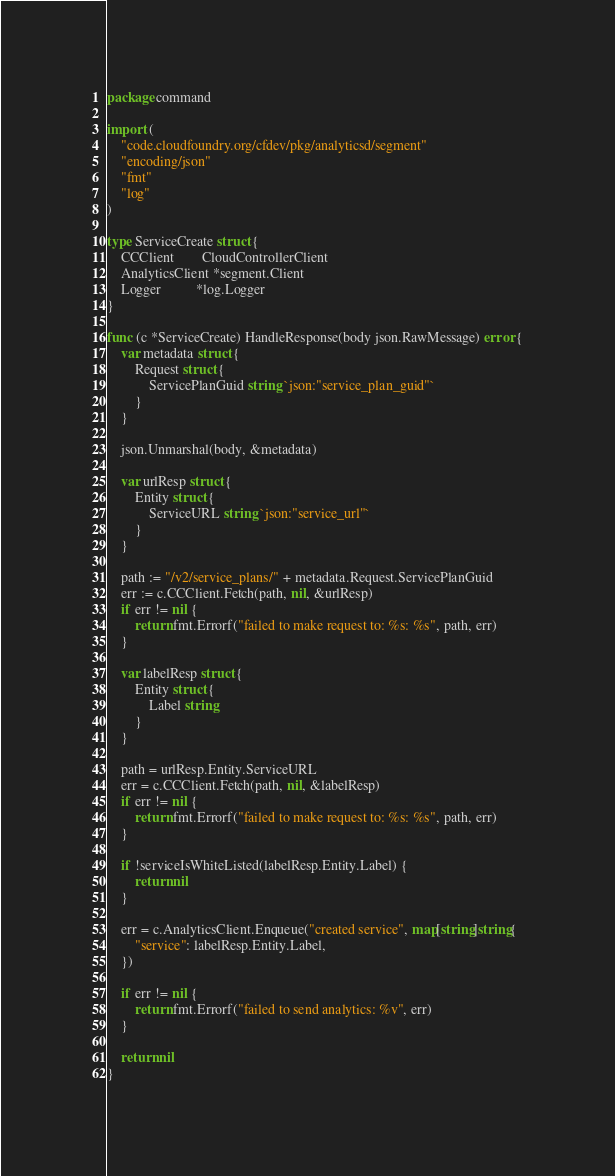<code> <loc_0><loc_0><loc_500><loc_500><_Go_>package command

import (
	"code.cloudfoundry.org/cfdev/pkg/analyticsd/segment"
	"encoding/json"
	"fmt"
	"log"
)

type ServiceCreate struct {
	CCClient        CloudControllerClient
	AnalyticsClient *segment.Client
	Logger          *log.Logger
}

func (c *ServiceCreate) HandleResponse(body json.RawMessage) error {
	var metadata struct {
		Request struct {
			ServicePlanGuid string `json:"service_plan_guid"`
		}
	}

	json.Unmarshal(body, &metadata)

	var urlResp struct {
		Entity struct {
			ServiceURL string `json:"service_url"`
		}
	}

	path := "/v2/service_plans/" + metadata.Request.ServicePlanGuid
	err := c.CCClient.Fetch(path, nil, &urlResp)
	if err != nil {
		return fmt.Errorf("failed to make request to: %s: %s", path, err)
	}

	var labelResp struct {
		Entity struct {
			Label string
		}
	}

	path = urlResp.Entity.ServiceURL
	err = c.CCClient.Fetch(path, nil, &labelResp)
	if err != nil {
		return fmt.Errorf("failed to make request to: %s: %s", path, err)
	}

	if !serviceIsWhiteListed(labelResp.Entity.Label) {
		return nil
	}

	err = c.AnalyticsClient.Enqueue("created service", map[string]string{
		"service": labelResp.Entity.Label,
	})

	if err != nil {
		return fmt.Errorf("failed to send analytics: %v", err)
	}

	return nil
}
</code> 